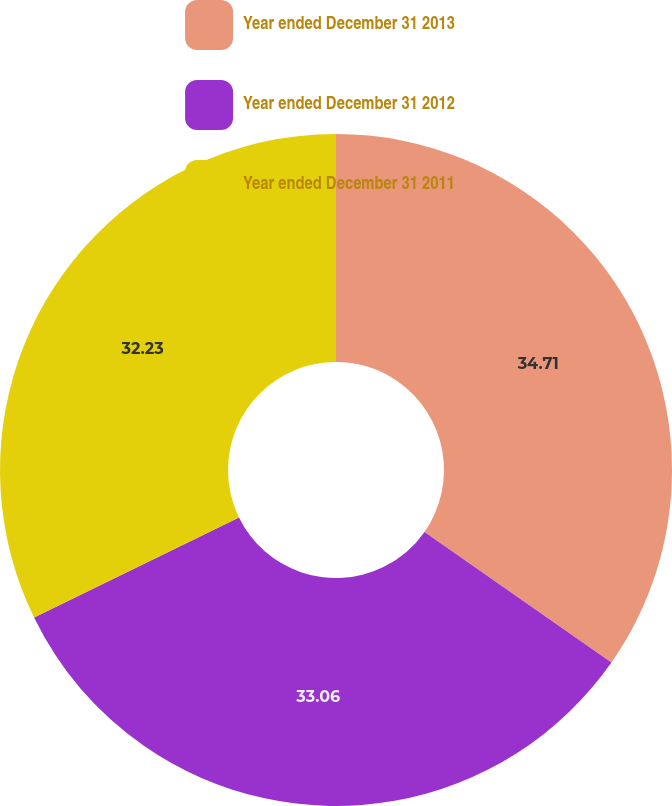<chart> <loc_0><loc_0><loc_500><loc_500><pie_chart><fcel>Year ended December 31 2013<fcel>Year ended December 31 2012<fcel>Year ended December 31 2011<nl><fcel>34.71%<fcel>33.06%<fcel>32.23%<nl></chart> 